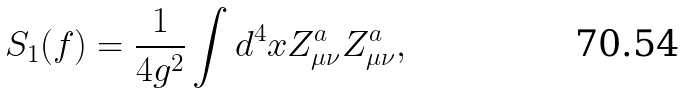Convert formula to latex. <formula><loc_0><loc_0><loc_500><loc_500>S _ { 1 } ( f ) = \frac { 1 } { 4 g ^ { 2 } } \int d ^ { 4 } x Z ^ { a } _ { \mu \nu } Z ^ { a } _ { \mu \nu } ,</formula> 